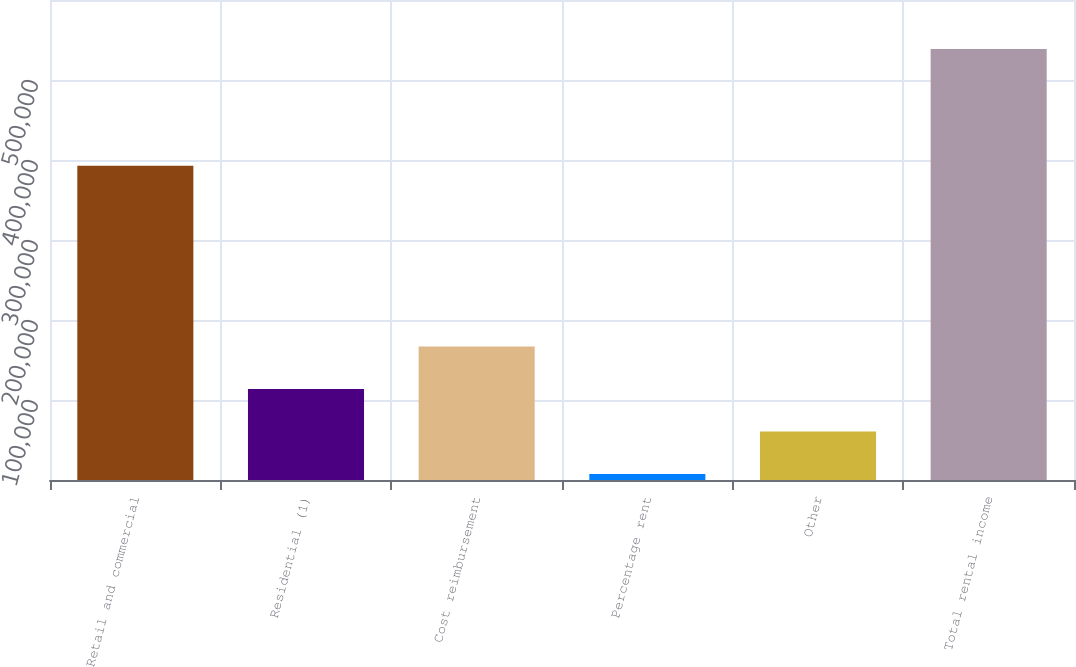<chart> <loc_0><loc_0><loc_500><loc_500><bar_chart><fcel>Retail and commercial<fcel>Residential (1)<fcel>Cost reimbursement<fcel>Percentage rent<fcel>Other<fcel>Total rental income<nl><fcel>392657<fcel>113801<fcel>166914<fcel>7576<fcel>60688.5<fcel>538701<nl></chart> 